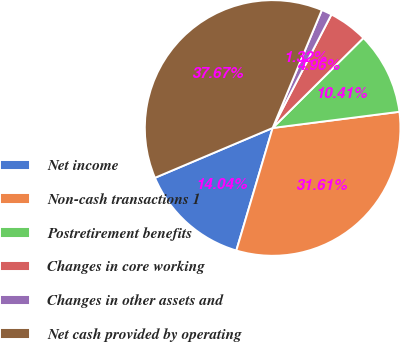Convert chart. <chart><loc_0><loc_0><loc_500><loc_500><pie_chart><fcel>Net income<fcel>Non-cash transactions 1<fcel>Postretirement benefits<fcel>Changes in core working<fcel>Changes in other assets and<fcel>Net cash provided by operating<nl><fcel>14.04%<fcel>31.61%<fcel>10.41%<fcel>4.96%<fcel>1.32%<fcel>37.67%<nl></chart> 